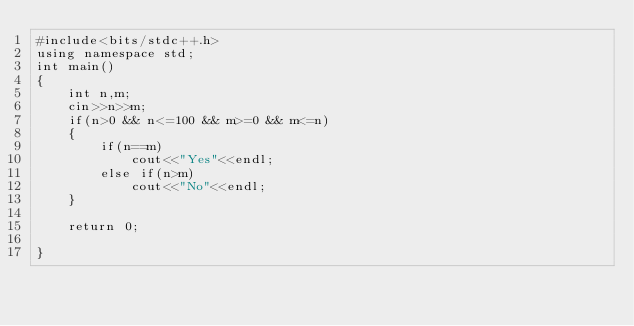Convert code to text. <code><loc_0><loc_0><loc_500><loc_500><_C++_>#include<bits/stdc++.h>
using namespace std;
int main()
{
    int n,m;
    cin>>n>>m;
    if(n>0 && n<=100 && m>=0 && m<=n)
    {
        if(n==m)
            cout<<"Yes"<<endl;
        else if(n>m)
            cout<<"No"<<endl;
    }

    return 0;

}
</code> 